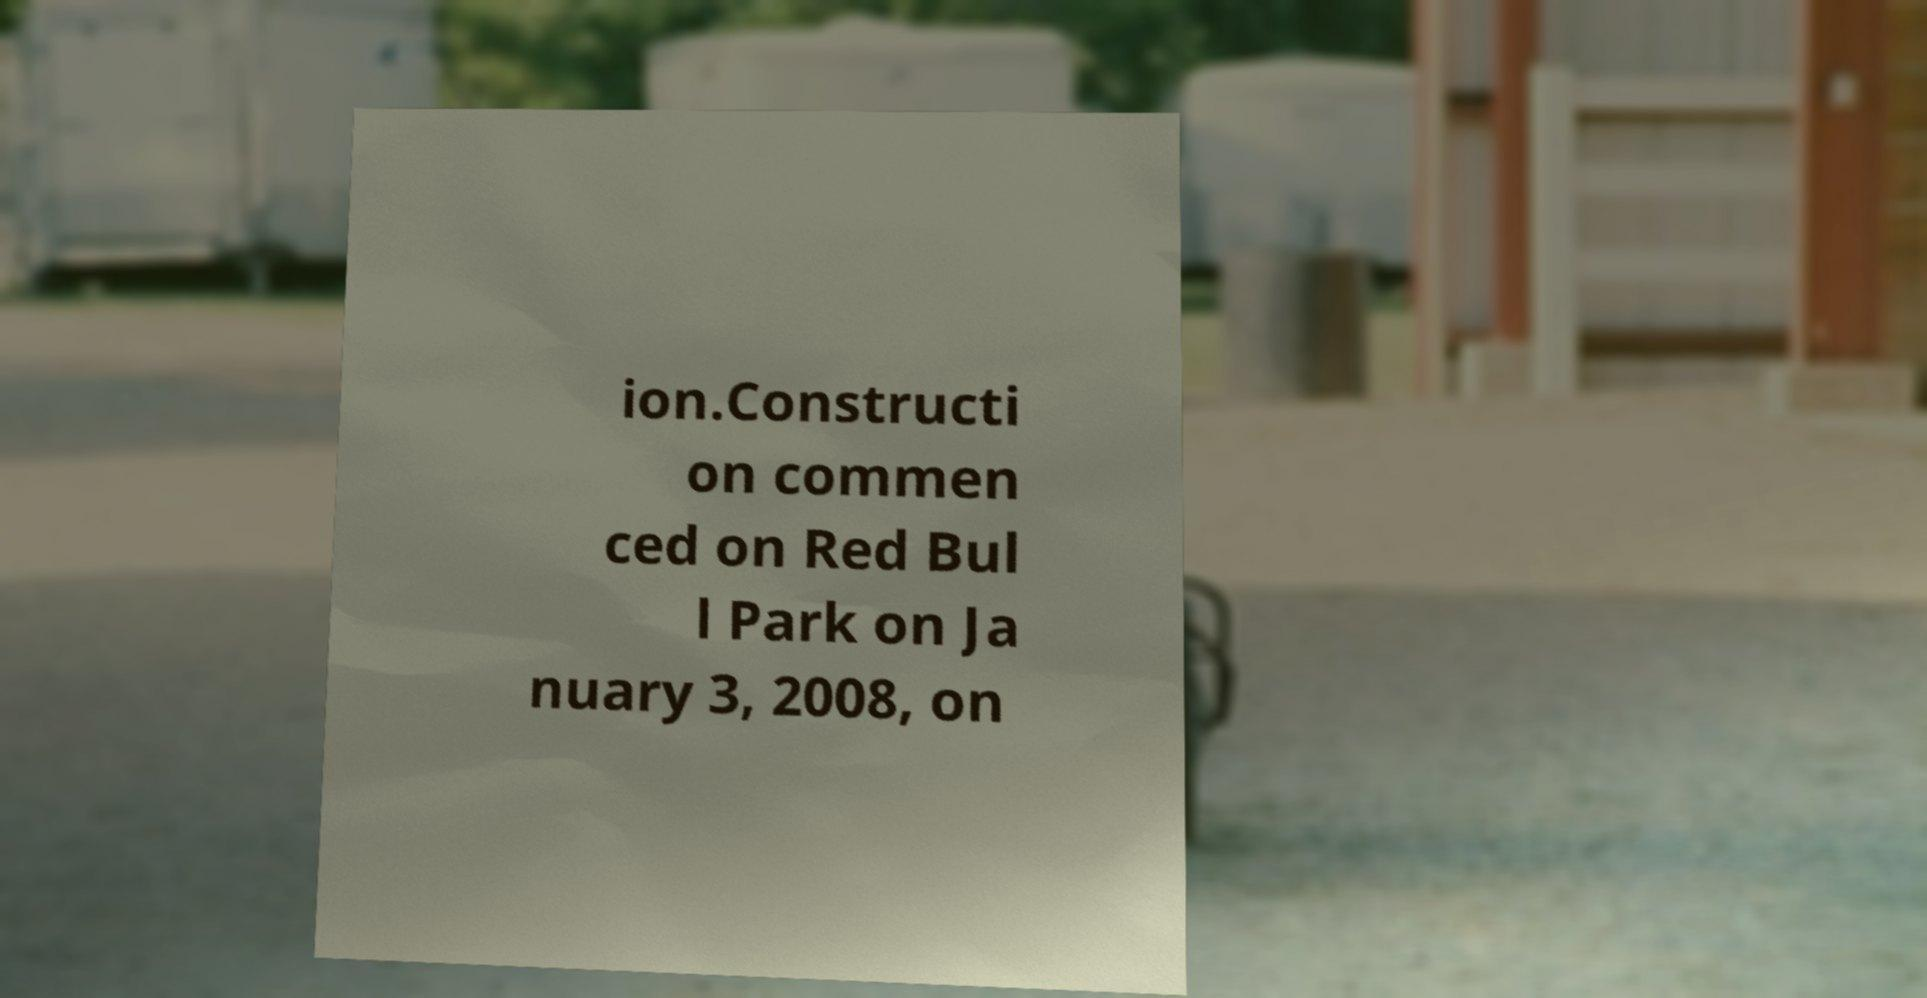Can you read and provide the text displayed in the image?This photo seems to have some interesting text. Can you extract and type it out for me? ion.Constructi on commen ced on Red Bul l Park on Ja nuary 3, 2008, on 